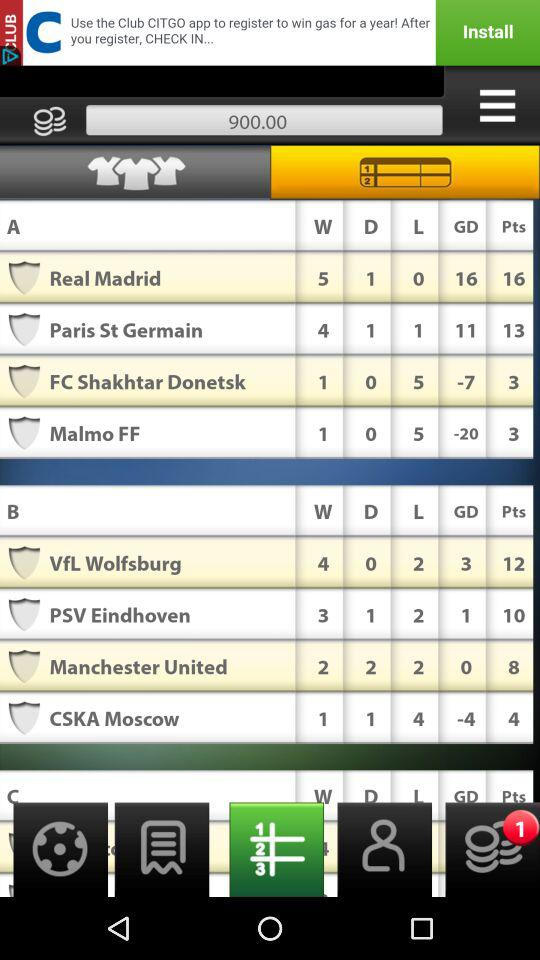What is the score of GD for "VfL Wolfsburg"? The score is 3. 